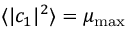Convert formula to latex. <formula><loc_0><loc_0><loc_500><loc_500>\langle | c _ { 1 } | ^ { 2 } \rangle = \mu _ { \max }</formula> 